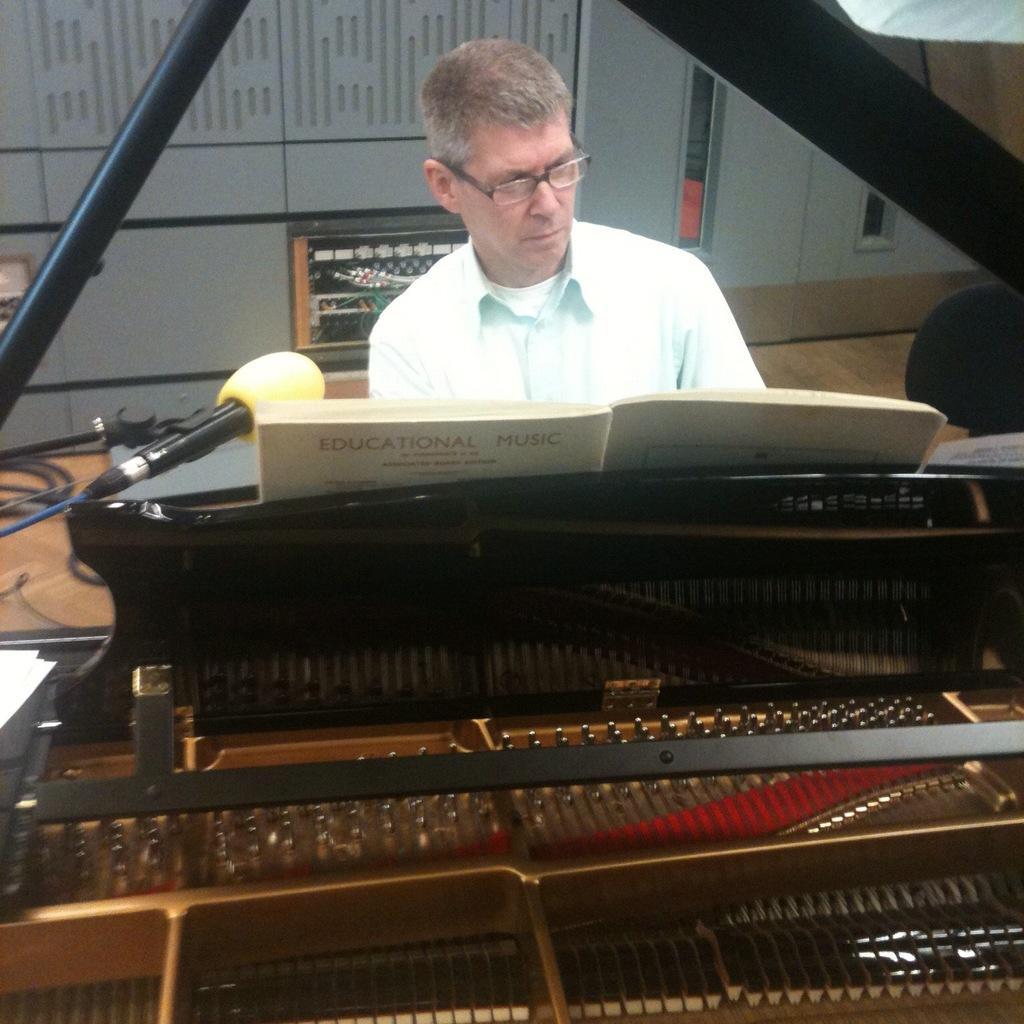Could you give a brief overview of what you see in this image? In the image we can see there is a man who is sitting in front of a piano. 